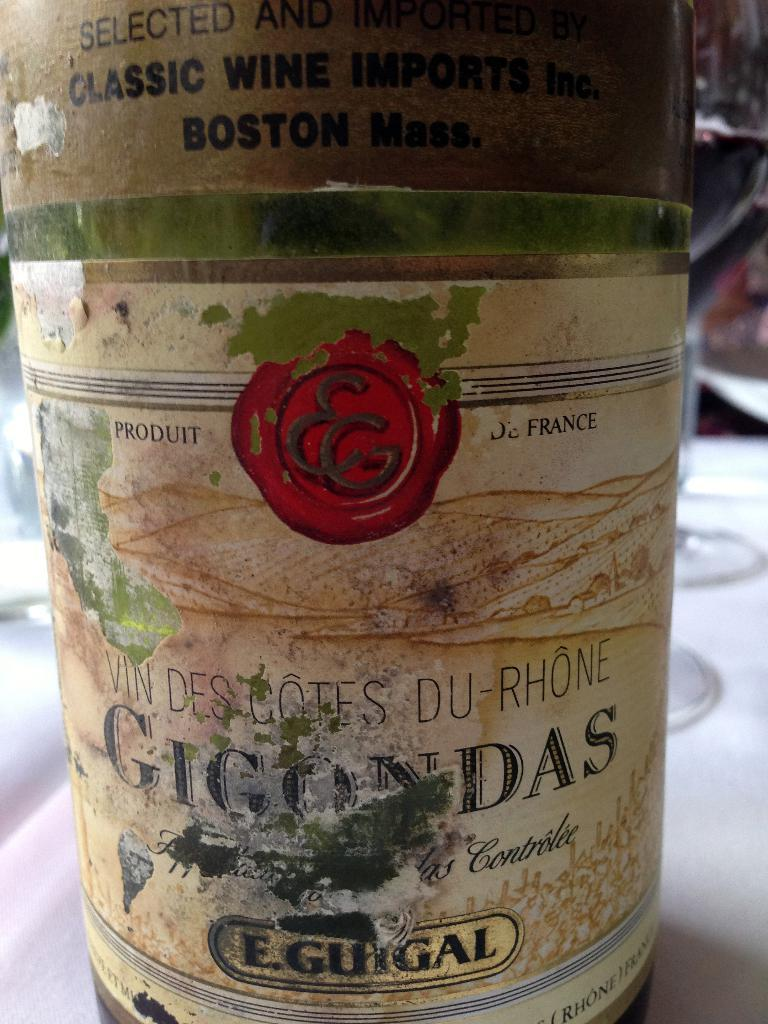<image>
Share a concise interpretation of the image provided. the word Guigal is on a bottle that is worn 